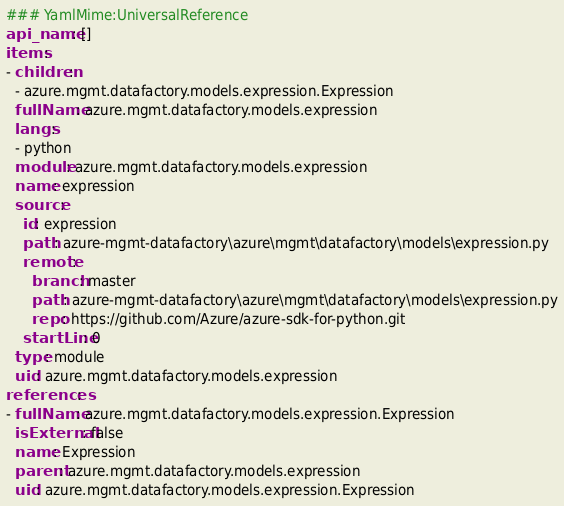Convert code to text. <code><loc_0><loc_0><loc_500><loc_500><_YAML_>### YamlMime:UniversalReference
api_name: []
items:
- children:
  - azure.mgmt.datafactory.models.expression.Expression
  fullName: azure.mgmt.datafactory.models.expression
  langs:
  - python
  module: azure.mgmt.datafactory.models.expression
  name: expression
  source:
    id: expression
    path: azure-mgmt-datafactory\azure\mgmt\datafactory\models\expression.py
    remote:
      branch: master
      path: azure-mgmt-datafactory\azure\mgmt\datafactory\models\expression.py
      repo: https://github.com/Azure/azure-sdk-for-python.git
    startLine: 0
  type: module
  uid: azure.mgmt.datafactory.models.expression
references:
- fullName: azure.mgmt.datafactory.models.expression.Expression
  isExternal: false
  name: Expression
  parent: azure.mgmt.datafactory.models.expression
  uid: azure.mgmt.datafactory.models.expression.Expression
</code> 